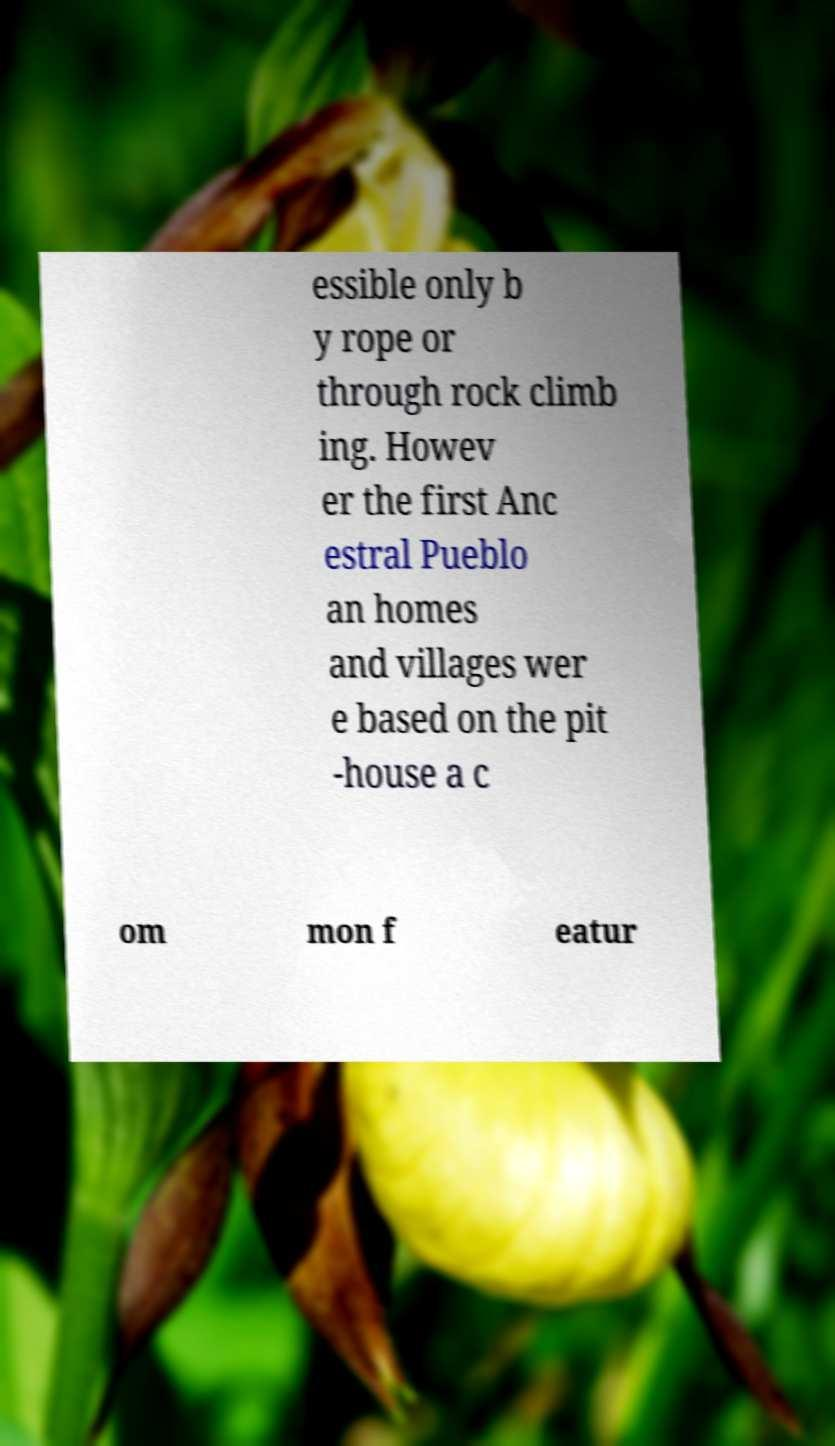I need the written content from this picture converted into text. Can you do that? essible only b y rope or through rock climb ing. Howev er the first Anc estral Pueblo an homes and villages wer e based on the pit -house a c om mon f eatur 